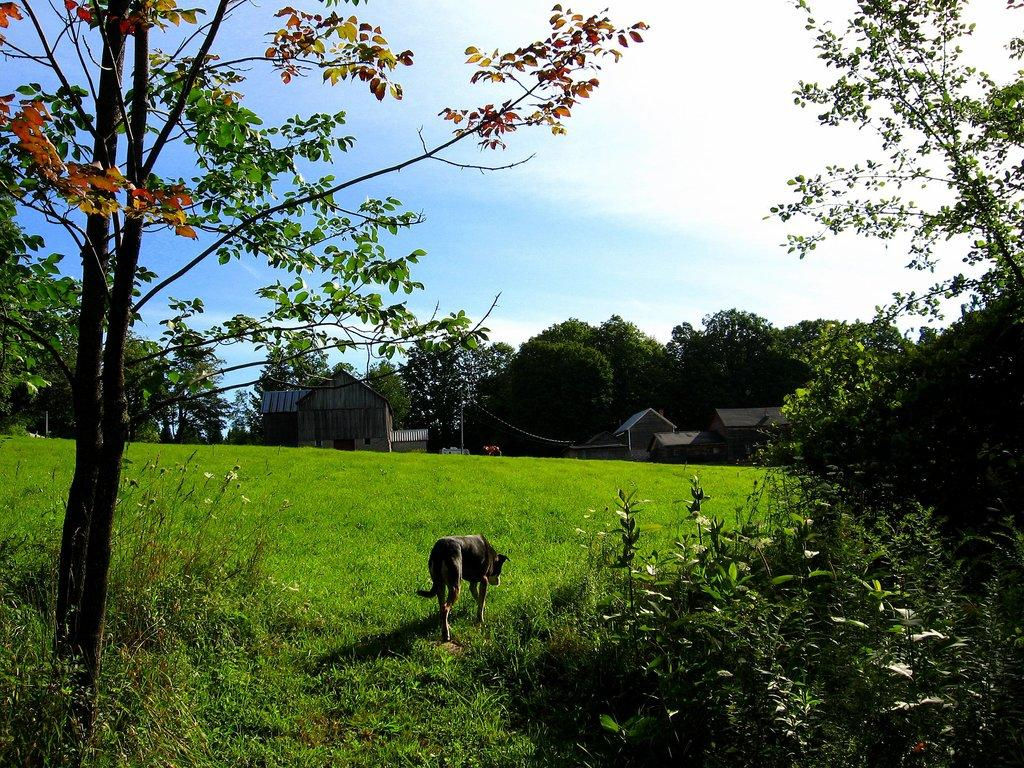What type of vegetation can be seen in the image? There are trees in the image. What animal is present on the grass in the image? There is a dog on the grass in the image. What structures can be seen in the distance in the image? There are houses in the background of the image. What part of the natural environment is visible in the image? The sky is visible in the background of the image. Where is the mark on the dog's face in the image? There is no mark on the dog's face in the image. What type of mask is the dog wearing in the image? There is no mask present on the dog in the image. 